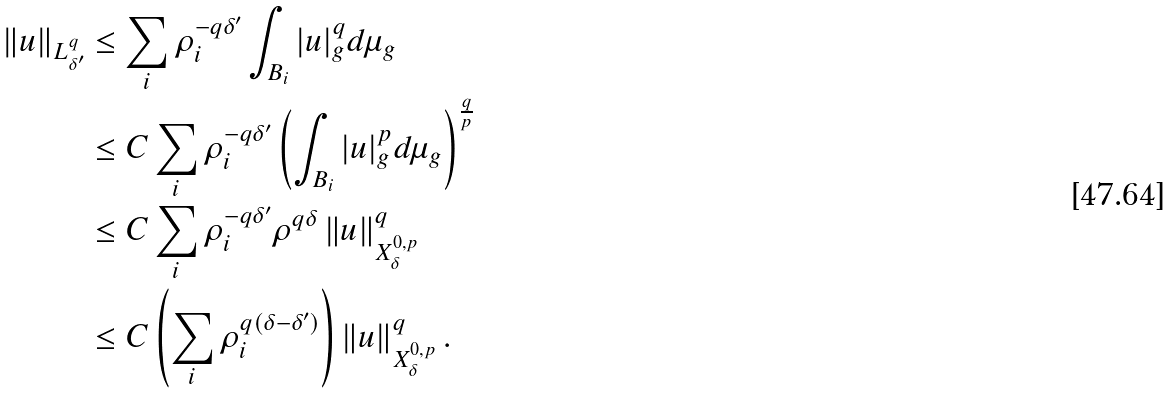<formula> <loc_0><loc_0><loc_500><loc_500>\left \| u \right \| _ { L ^ { q } _ { \delta ^ { \prime } } } & \leq \sum _ { i } \rho _ { i } ^ { - q \delta ^ { \prime } } \int _ { B _ { i } } | u | _ { g } ^ { q } d \mu _ { g } \\ & \leq C \sum _ { i } \rho _ { i } ^ { - q \delta ^ { \prime } } \left ( \int _ { B _ { i } } | u | _ { g } ^ { p } d \mu _ { g } \right ) ^ { \frac { q } { p } } \\ & \leq C \sum _ { i } \rho _ { i } ^ { - q \delta ^ { \prime } } \rho ^ { q \delta } \left \| u \right \| ^ { q } _ { X ^ { 0 , p } _ { \delta } } \\ & \leq C \left ( \sum _ { i } \rho _ { i } ^ { q ( \delta - \delta ^ { \prime } ) } \right ) \left \| u \right \| ^ { q } _ { X ^ { 0 , p } _ { \delta } } .</formula> 